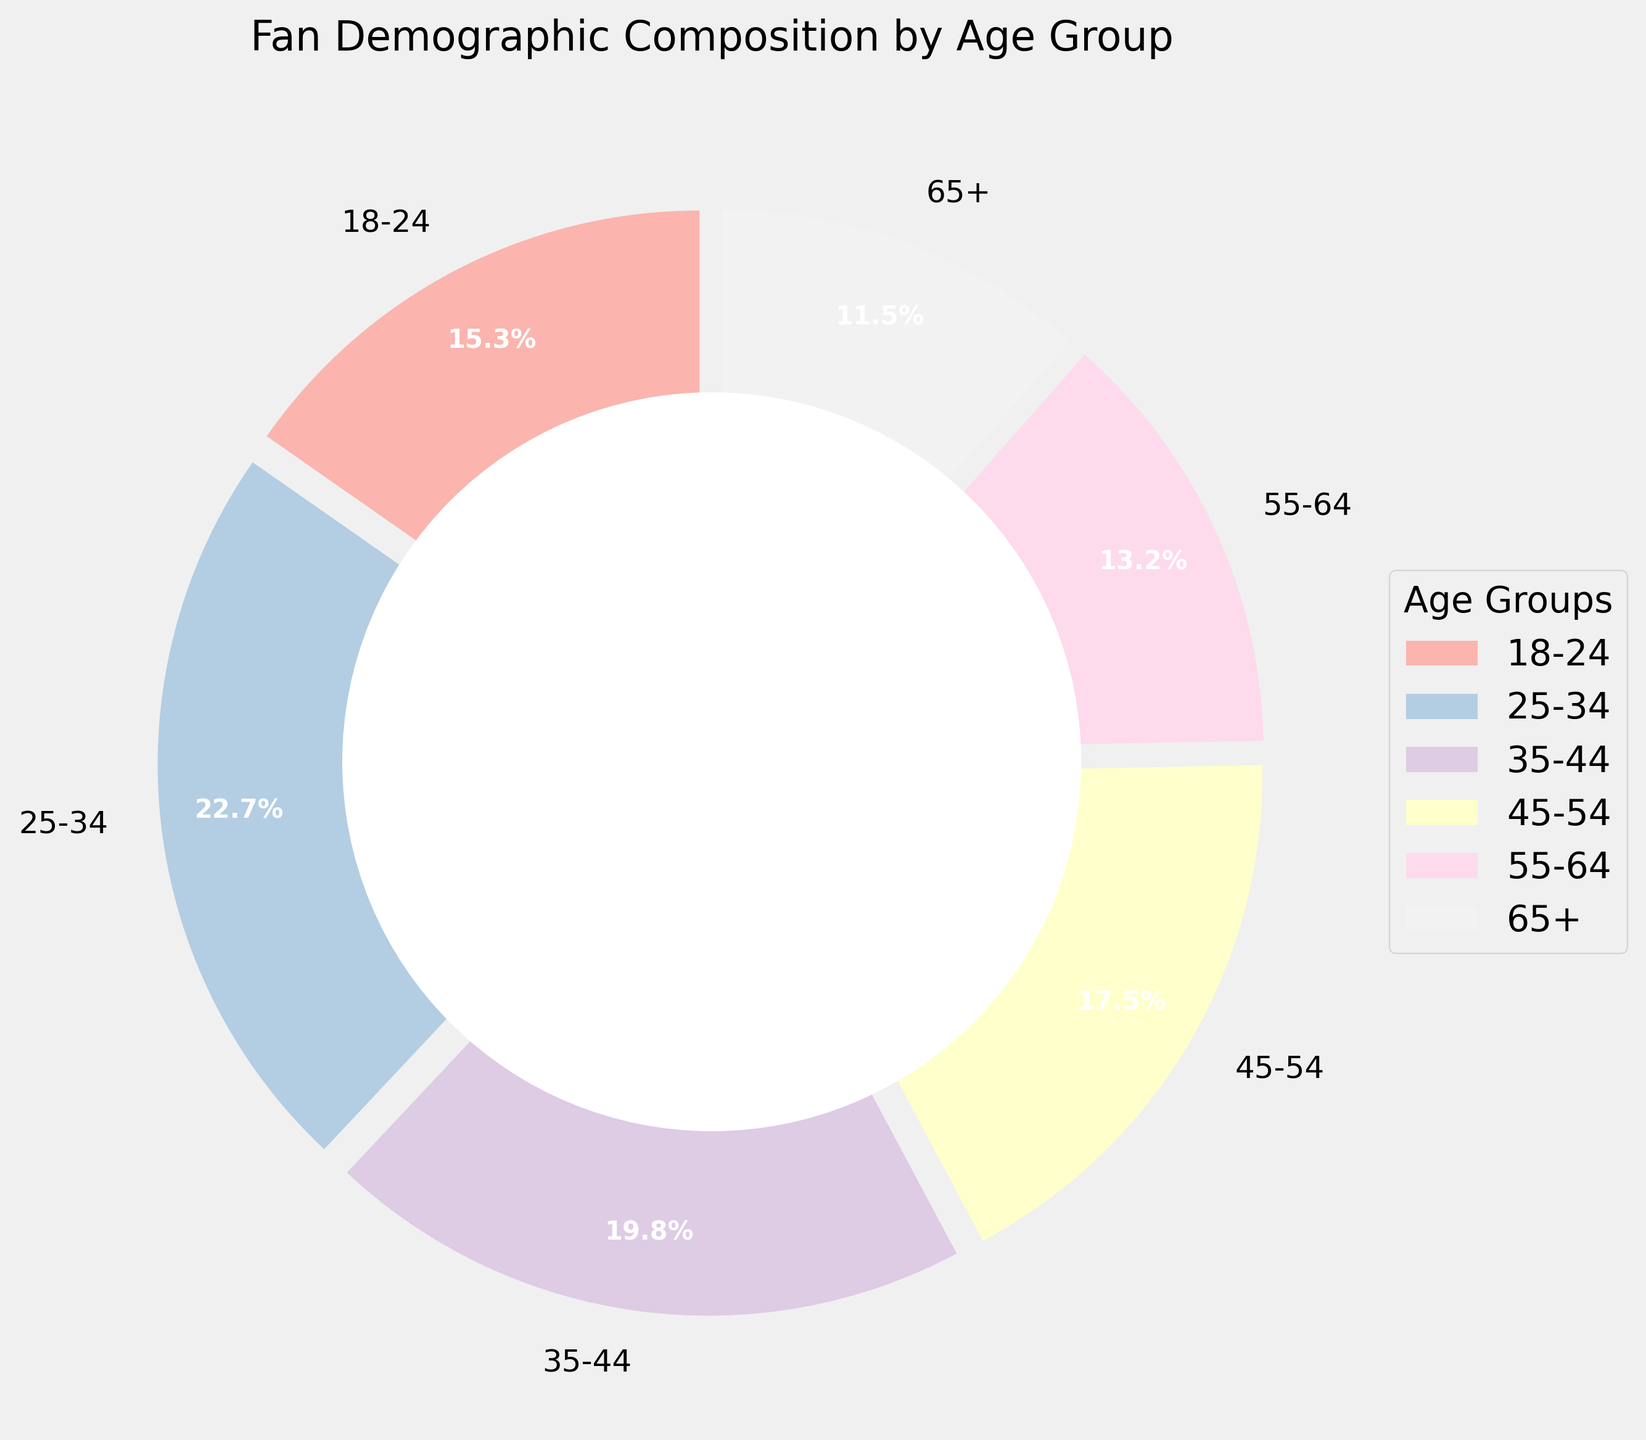What's the percentage of fans aged 25-34? The pie chart shows each age group's demographic composition in percentage form. The segment labeled '25-34' shows 22.7%.
Answer: 22.7% Which age group makes up the smallest percentage of fans? The pie chart segments each age group with their corresponding percentages. The '65+' segment has the smallest value of 11.5%.
Answer: 65+ How much greater is the percentage of fans aged 25-34 compared to those aged 18-24? The percentage for the '25-34' group is 22.7%, and for the '18-24' group, it is 15.3%. Subtract 15.3 from 22.7 to find the difference: 22.7 - 15.3 = 7.4%.
Answer: 7.4% Which two age groups together make up more than 40% of the fans? By adding the percentages of the two highest values, we see '25-34' and '35-44' add up to 22.7% + 19.8% = 42.5%, which is greater than 40%.
Answer: 25-34 and 35-44 What's the average percentage of fans aged between 45 and 64? The percentages for the '45-54' and '55-64' age groups are 17.5% and 13.2%, respectively. The average is calculated as (17.5 + 13.2) / 2 = 15.35%.
Answer: 15.35% What color is the segment representing fans aged 55-64? Each segment in the pie chart is colored differently. The '55-64' segment is colored based on the pastel color palette but needs to be visually identified from the chart's legend and color distribution.
Answer: Pastel pink/beige (visual identification needed) How does the middle age group's percentage compare to the oldest group's percentage? The middle age group '45-54' has 17.5%, and the oldest group '65+' has 11.5%. 17.5% is greater than 11.5%.
Answer: 17.5% is greater than 11.5% What is the sum of the percentages for fans aged under 35? The '18-24' and '25-34' age groups are under 35. Add their percentages: 15.3% + 22.7% = 38.0%.
Answer: 38.0% Which age group is represented in the segment that appears closest to the legend? Typically, the legend is placed near segments starting from the right of the vertical axis (12 o'clock position). Identifying visually near the legend on the diagram shows the related segment.
Answer: Visually identified (nearest to legend) What proportion of the fans are 35 years old or younger? Combine the percentages of '18-24', '25-34' and '35-44' groups: 15.3% + 22.7% + 19.8% = 57.8%.
Answer: 57.8% 